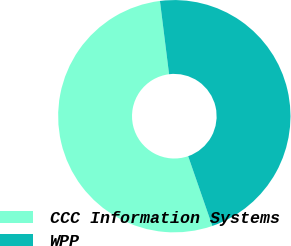Convert chart. <chart><loc_0><loc_0><loc_500><loc_500><pie_chart><fcel>CCC Information Systems<fcel>WPP<nl><fcel>53.33%<fcel>46.67%<nl></chart> 